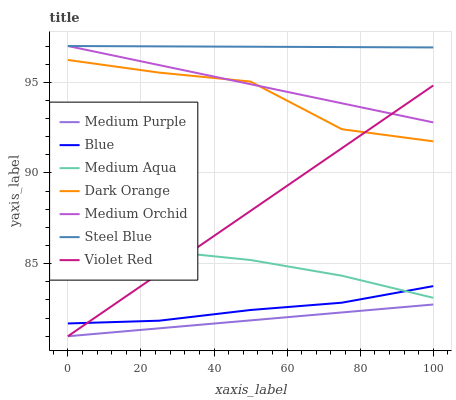Does Medium Purple have the minimum area under the curve?
Answer yes or no. Yes. Does Steel Blue have the maximum area under the curve?
Answer yes or no. Yes. Does Dark Orange have the minimum area under the curve?
Answer yes or no. No. Does Dark Orange have the maximum area under the curve?
Answer yes or no. No. Is Violet Red the smoothest?
Answer yes or no. Yes. Is Dark Orange the roughest?
Answer yes or no. Yes. Is Dark Orange the smoothest?
Answer yes or no. No. Is Violet Red the roughest?
Answer yes or no. No. Does Violet Red have the lowest value?
Answer yes or no. Yes. Does Dark Orange have the lowest value?
Answer yes or no. No. Does Steel Blue have the highest value?
Answer yes or no. Yes. Does Dark Orange have the highest value?
Answer yes or no. No. Is Violet Red less than Steel Blue?
Answer yes or no. Yes. Is Dark Orange greater than Medium Purple?
Answer yes or no. Yes. Does Violet Red intersect Medium Purple?
Answer yes or no. Yes. Is Violet Red less than Medium Purple?
Answer yes or no. No. Is Violet Red greater than Medium Purple?
Answer yes or no. No. Does Violet Red intersect Steel Blue?
Answer yes or no. No. 